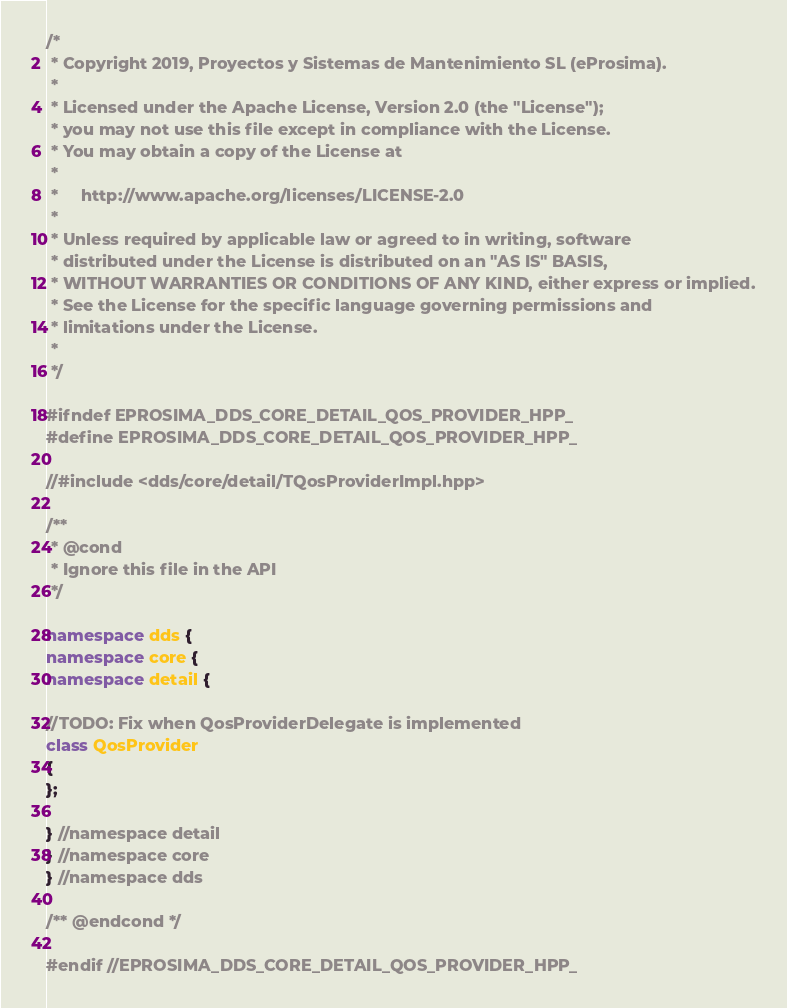Convert code to text. <code><loc_0><loc_0><loc_500><loc_500><_C++_>/*
 * Copyright 2019, Proyectos y Sistemas de Mantenimiento SL (eProsima).
 *
 * Licensed under the Apache License, Version 2.0 (the "License");
 * you may not use this file except in compliance with the License.
 * You may obtain a copy of the License at
 *
 *     http://www.apache.org/licenses/LICENSE-2.0
 *
 * Unless required by applicable law or agreed to in writing, software
 * distributed under the License is distributed on an "AS IS" BASIS,
 * WITHOUT WARRANTIES OR CONDITIONS OF ANY KIND, either express or implied.
 * See the License for the specific language governing permissions and
 * limitations under the License.
 *
 */

#ifndef EPROSIMA_DDS_CORE_DETAIL_QOS_PROVIDER_HPP_
#define EPROSIMA_DDS_CORE_DETAIL_QOS_PROVIDER_HPP_

//#include <dds/core/detail/TQosProviderImpl.hpp>

/**
 * @cond
 * Ignore this file in the API
 */

namespace dds {
namespace core {
namespace detail {

//TODO: Fix when QosProviderDelegate is implemented
class QosProvider
{
};

} //namespace detail
} //namespace core
} //namespace dds

/** @endcond */

#endif //EPROSIMA_DDS_CORE_DETAIL_QOS_PROVIDER_HPP_
</code> 